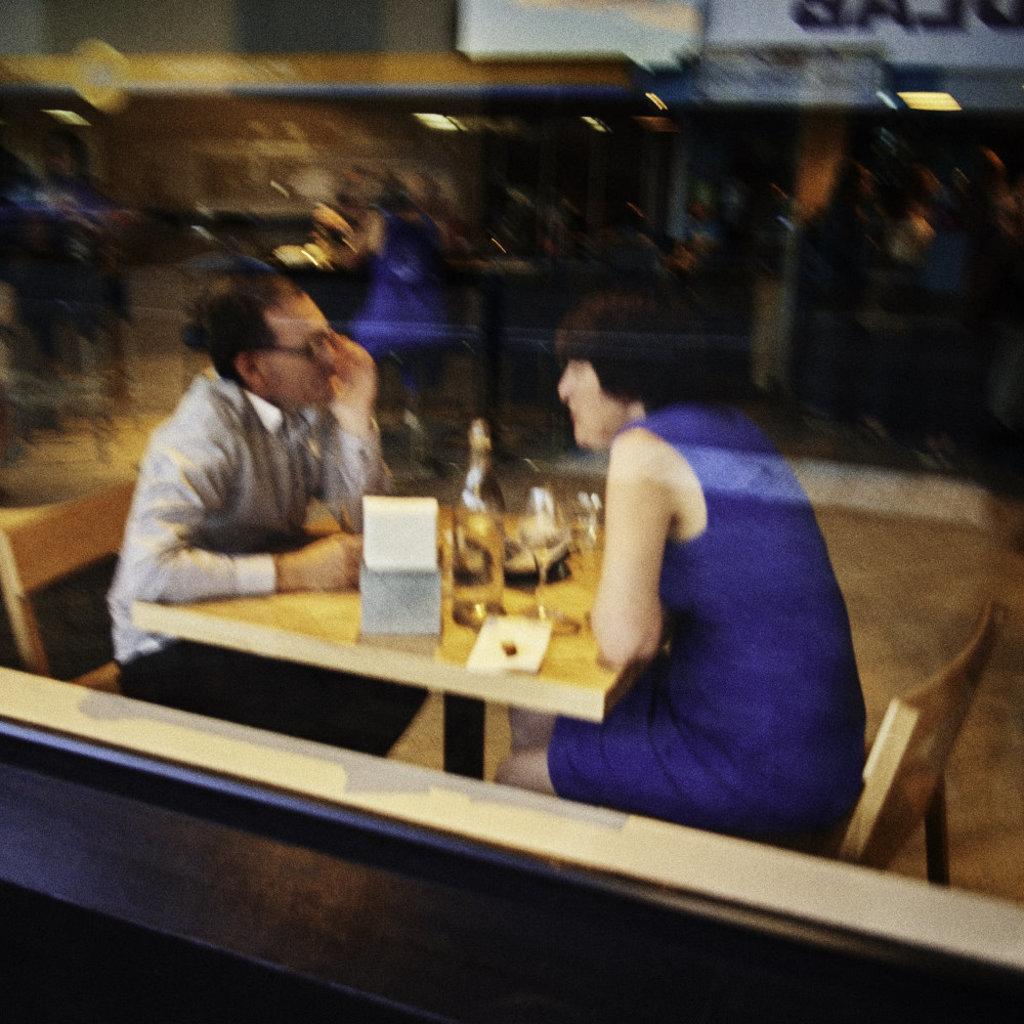Please provide a concise description of this image. In this picture we can see man and woman are sitting on chair and in front of them there is table and on table we can see bottle, glass, stand and in the background we can see group of people and it is blur. 